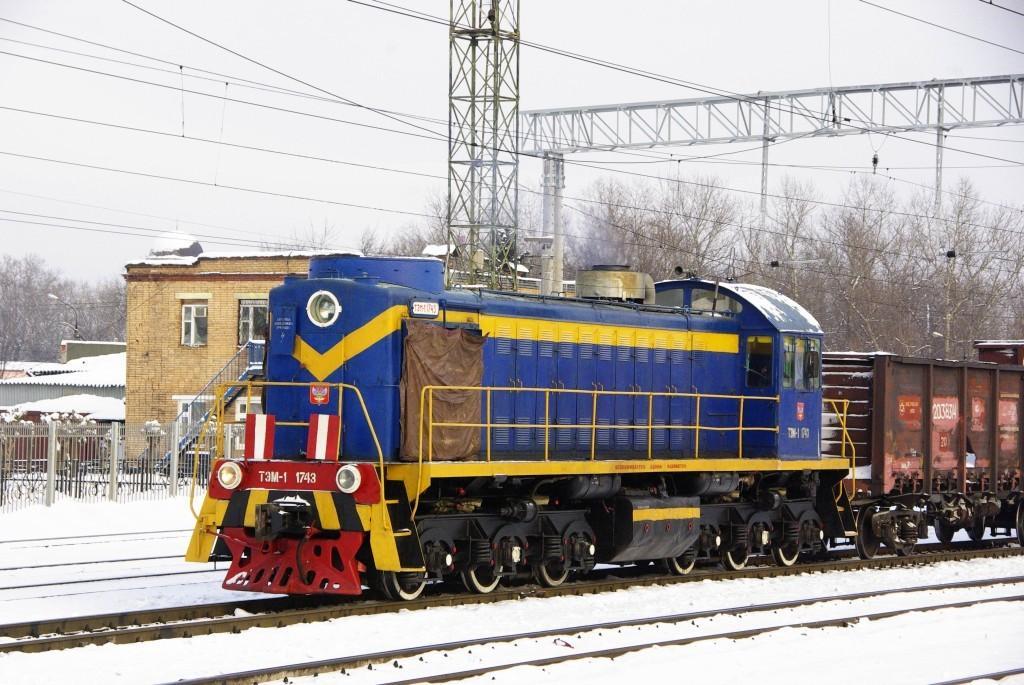In one or two sentences, can you explain what this image depicts? In this picture there is a train in the center of the image and there are sheds on the left side of the image, there is snow at the bottom side of the image and there are trees in the background area of the image. 